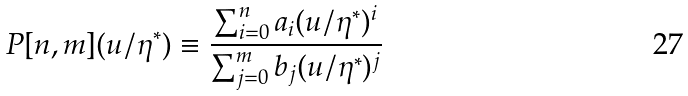<formula> <loc_0><loc_0><loc_500><loc_500>P [ n , m ] ( u / \eta ^ { * } ) \equiv \frac { \sum _ { i = 0 } ^ { n } a _ { i } ( u / \eta ^ { * } ) ^ { i } } { \sum _ { j = 0 } ^ { m } b _ { j } ( u / \eta ^ { * } ) ^ { j } }</formula> 